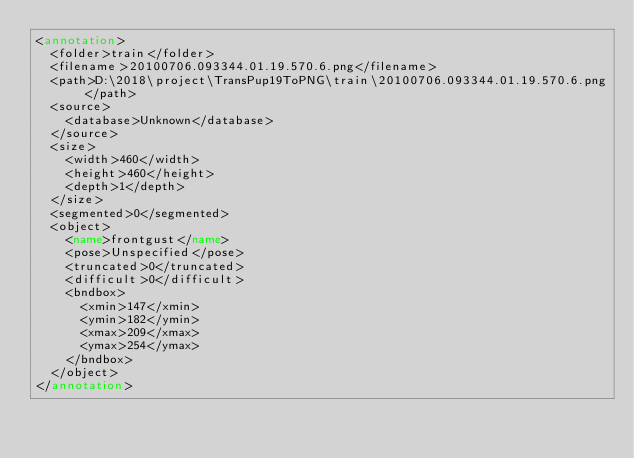<code> <loc_0><loc_0><loc_500><loc_500><_XML_><annotation>
	<folder>train</folder>
	<filename>20100706.093344.01.19.570.6.png</filename>
	<path>D:\2018\project\TransPup19ToPNG\train\20100706.093344.01.19.570.6.png</path>
	<source>
		<database>Unknown</database>
	</source>
	<size>
		<width>460</width>
		<height>460</height>
		<depth>1</depth>
	</size>
	<segmented>0</segmented>
	<object>
		<name>frontgust</name>
		<pose>Unspecified</pose>
		<truncated>0</truncated>
		<difficult>0</difficult>
		<bndbox>
			<xmin>147</xmin>
			<ymin>182</ymin>
			<xmax>209</xmax>
			<ymax>254</ymax>
		</bndbox>
	</object>
</annotation>
</code> 